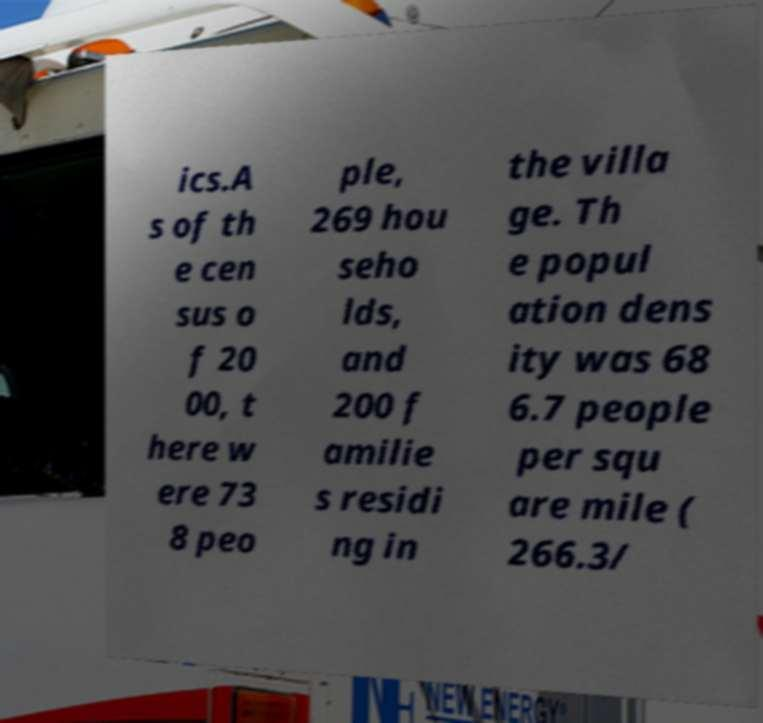What messages or text are displayed in this image? I need them in a readable, typed format. ics.A s of th e cen sus o f 20 00, t here w ere 73 8 peo ple, 269 hou seho lds, and 200 f amilie s residi ng in the villa ge. Th e popul ation dens ity was 68 6.7 people per squ are mile ( 266.3/ 